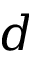<formula> <loc_0><loc_0><loc_500><loc_500>d</formula> 